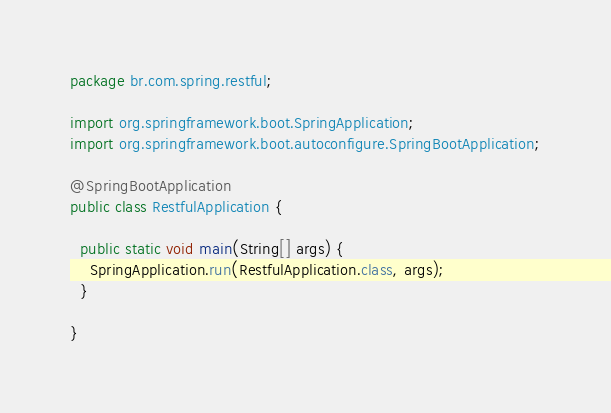Convert code to text. <code><loc_0><loc_0><loc_500><loc_500><_Java_>package br.com.spring.restful;

import org.springframework.boot.SpringApplication;
import org.springframework.boot.autoconfigure.SpringBootApplication;

@SpringBootApplication
public class RestfulApplication {

  public static void main(String[] args) {
    SpringApplication.run(RestfulApplication.class, args);
  }

}
</code> 